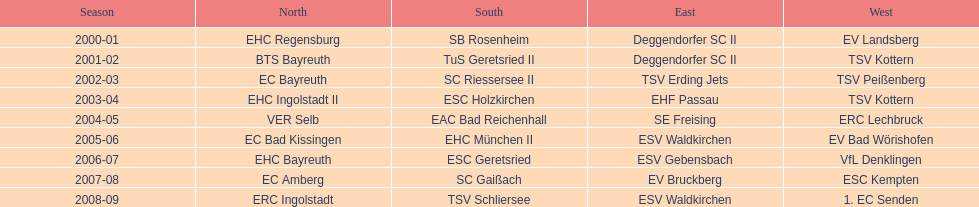Which teams played in the north? EHC Regensburg, BTS Bayreuth, EC Bayreuth, EHC Ingolstadt II, VER Selb, EC Bad Kissingen, EHC Bayreuth, EC Amberg, ERC Ingolstadt. Of these teams, which played during 2000-2001? EHC Regensburg. 